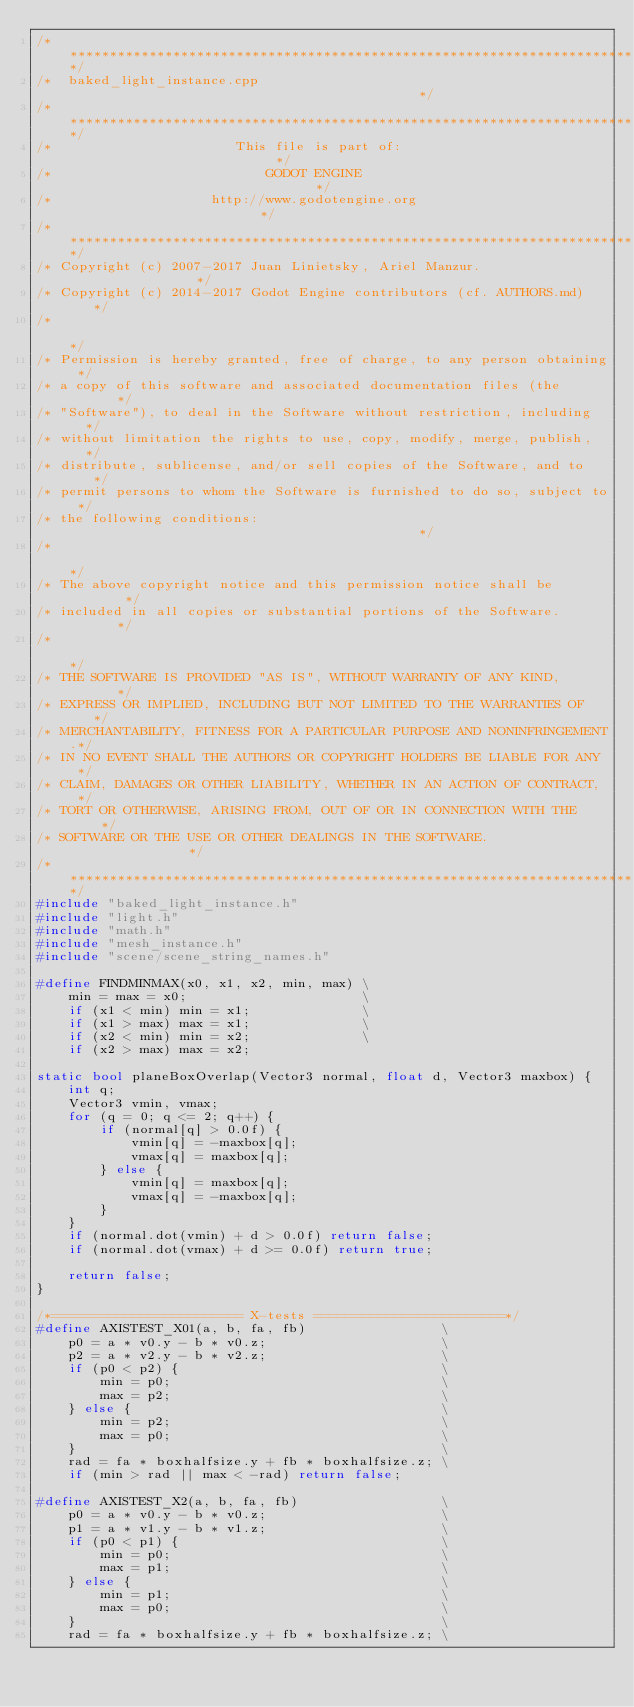<code> <loc_0><loc_0><loc_500><loc_500><_C++_>/*************************************************************************/
/*  baked_light_instance.cpp                                             */
/*************************************************************************/
/*                       This file is part of:                           */
/*                           GODOT ENGINE                                */
/*                    http://www.godotengine.org                         */
/*************************************************************************/
/* Copyright (c) 2007-2017 Juan Linietsky, Ariel Manzur.                 */
/* Copyright (c) 2014-2017 Godot Engine contributors (cf. AUTHORS.md)    */
/*                                                                       */
/* Permission is hereby granted, free of charge, to any person obtaining */
/* a copy of this software and associated documentation files (the       */
/* "Software"), to deal in the Software without restriction, including   */
/* without limitation the rights to use, copy, modify, merge, publish,   */
/* distribute, sublicense, and/or sell copies of the Software, and to    */
/* permit persons to whom the Software is furnished to do so, subject to */
/* the following conditions:                                             */
/*                                                                       */
/* The above copyright notice and this permission notice shall be        */
/* included in all copies or substantial portions of the Software.       */
/*                                                                       */
/* THE SOFTWARE IS PROVIDED "AS IS", WITHOUT WARRANTY OF ANY KIND,       */
/* EXPRESS OR IMPLIED, INCLUDING BUT NOT LIMITED TO THE WARRANTIES OF    */
/* MERCHANTABILITY, FITNESS FOR A PARTICULAR PURPOSE AND NONINFRINGEMENT.*/
/* IN NO EVENT SHALL THE AUTHORS OR COPYRIGHT HOLDERS BE LIABLE FOR ANY  */
/* CLAIM, DAMAGES OR OTHER LIABILITY, WHETHER IN AN ACTION OF CONTRACT,  */
/* TORT OR OTHERWISE, ARISING FROM, OUT OF OR IN CONNECTION WITH THE     */
/* SOFTWARE OR THE USE OR OTHER DEALINGS IN THE SOFTWARE.                */
/*************************************************************************/
#include "baked_light_instance.h"
#include "light.h"
#include "math.h"
#include "mesh_instance.h"
#include "scene/scene_string_names.h"

#define FINDMINMAX(x0, x1, x2, min, max) \
	min = max = x0;                      \
	if (x1 < min) min = x1;              \
	if (x1 > max) max = x1;              \
	if (x2 < min) min = x2;              \
	if (x2 > max) max = x2;

static bool planeBoxOverlap(Vector3 normal, float d, Vector3 maxbox) {
	int q;
	Vector3 vmin, vmax;
	for (q = 0; q <= 2; q++) {
		if (normal[q] > 0.0f) {
			vmin[q] = -maxbox[q];
			vmax[q] = maxbox[q];
		} else {
			vmin[q] = maxbox[q];
			vmax[q] = -maxbox[q];
		}
	}
	if (normal.dot(vmin) + d > 0.0f) return false;
	if (normal.dot(vmax) + d >= 0.0f) return true;

	return false;
}

/*======================== X-tests ========================*/
#define AXISTEST_X01(a, b, fa, fb)                 \
	p0 = a * v0.y - b * v0.z;                      \
	p2 = a * v2.y - b * v2.z;                      \
	if (p0 < p2) {                                 \
		min = p0;                                  \
		max = p2;                                  \
	} else {                                       \
		min = p2;                                  \
		max = p0;                                  \
	}                                              \
	rad = fa * boxhalfsize.y + fb * boxhalfsize.z; \
	if (min > rad || max < -rad) return false;

#define AXISTEST_X2(a, b, fa, fb)                  \
	p0 = a * v0.y - b * v0.z;                      \
	p1 = a * v1.y - b * v1.z;                      \
	if (p0 < p1) {                                 \
		min = p0;                                  \
		max = p1;                                  \
	} else {                                       \
		min = p1;                                  \
		max = p0;                                  \
	}                                              \
	rad = fa * boxhalfsize.y + fb * boxhalfsize.z; \</code> 